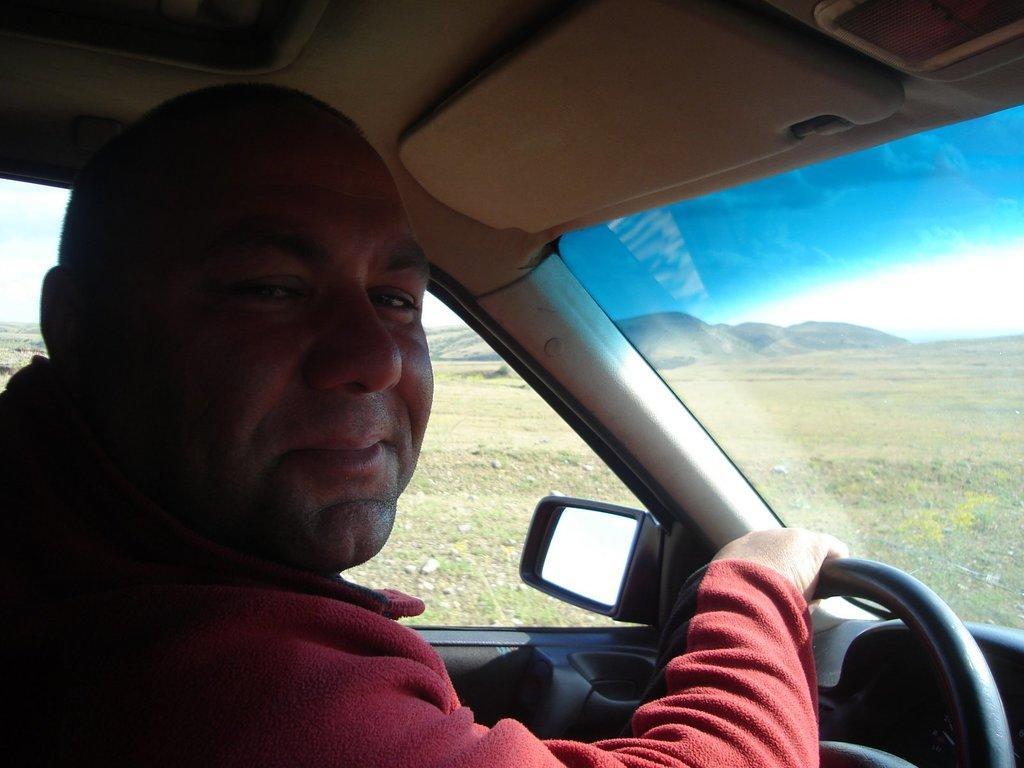Describe this image in one or two sentences. In the picture we can see a person driving a car, he is wearing a red color sweater and holding a steering and to the car we can see a side mirror and windshield and from it we can see a grass surface and far away from it we can see some hills and sky. 